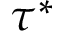Convert formula to latex. <formula><loc_0><loc_0><loc_500><loc_500>\tau ^ { * }</formula> 